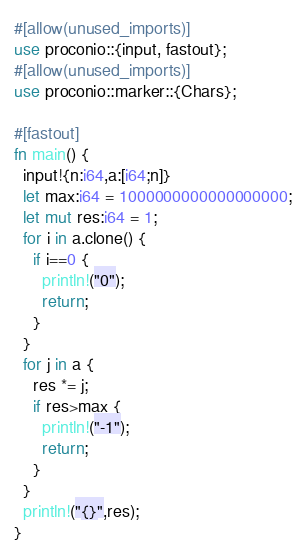<code> <loc_0><loc_0><loc_500><loc_500><_Rust_>#[allow(unused_imports)]
use proconio::{input, fastout};
#[allow(unused_imports)]
use proconio::marker::{Chars};

#[fastout]
fn main() {
  input!{n:i64,a:[i64;n]}
  let max:i64 = 1000000000000000000;
  let mut res:i64 = 1;
  for i in a.clone() {
    if i==0 {
      println!("0");
      return;
    }
  }
  for j in a {
    res *= j;
    if res>max {
      println!("-1");
      return;
    }
  }
  println!("{}",res);
}
</code> 